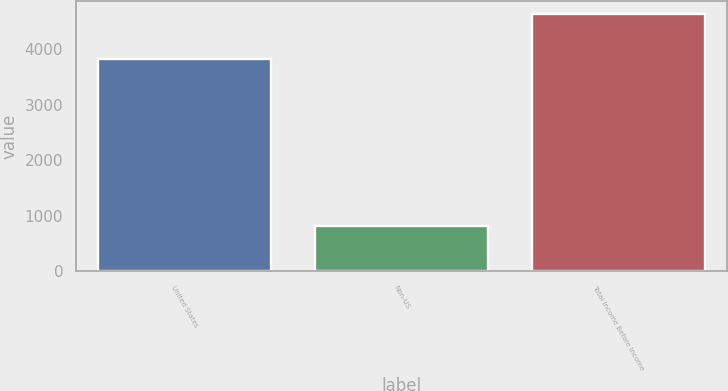Convert chart. <chart><loc_0><loc_0><loc_500><loc_500><bar_chart><fcel>United States<fcel>Non-US<fcel>Total Income Before Income<nl><fcel>3819<fcel>818<fcel>4637<nl></chart> 